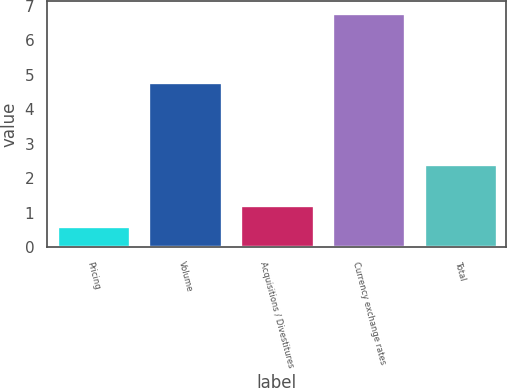Convert chart to OTSL. <chart><loc_0><loc_0><loc_500><loc_500><bar_chart><fcel>Pricing<fcel>Volume<fcel>Acquisitions / Divestitures<fcel>Currency exchange rates<fcel>Total<nl><fcel>0.6<fcel>4.8<fcel>1.22<fcel>6.8<fcel>2.4<nl></chart> 